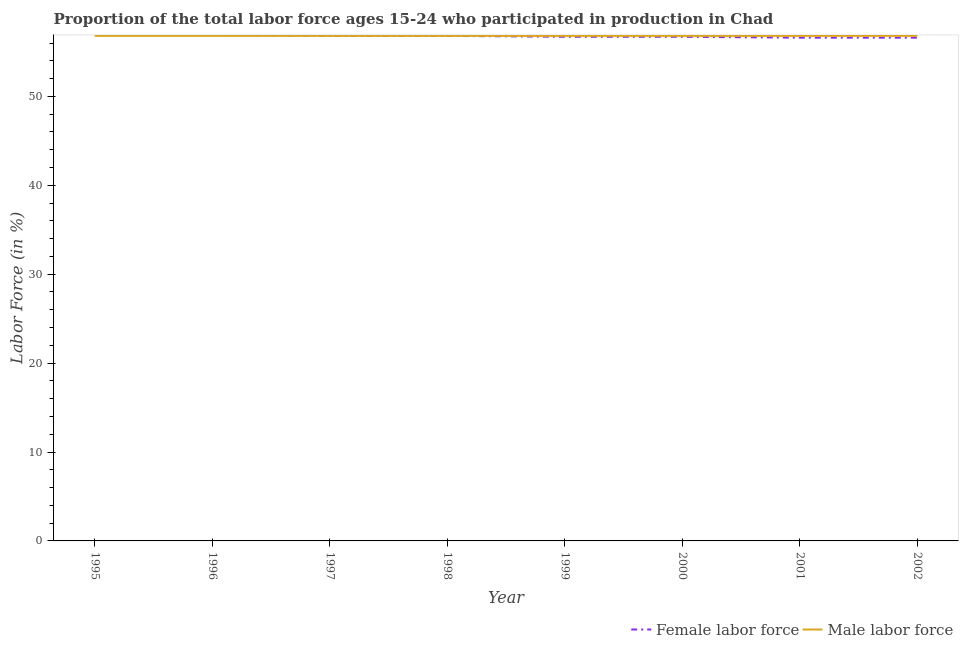How many different coloured lines are there?
Keep it short and to the point. 2. What is the percentage of male labour force in 1998?
Keep it short and to the point. 56.8. Across all years, what is the maximum percentage of female labor force?
Offer a very short reply. 56.9. Across all years, what is the minimum percentage of male labour force?
Your response must be concise. 56.8. In which year was the percentage of male labour force maximum?
Provide a short and direct response. 1995. In which year was the percentage of female labor force minimum?
Provide a succinct answer. 2001. What is the total percentage of male labour force in the graph?
Make the answer very short. 454.4. What is the difference between the percentage of female labor force in 1998 and that in 2001?
Provide a succinct answer. 0.2. What is the difference between the percentage of female labor force in 1998 and the percentage of male labour force in 2001?
Offer a very short reply. 0. What is the average percentage of female labor force per year?
Your response must be concise. 56.75. In the year 1998, what is the difference between the percentage of female labor force and percentage of male labour force?
Your response must be concise. 0. In how many years, is the percentage of male labour force greater than 36 %?
Provide a succinct answer. 8. What is the difference between the highest and the lowest percentage of female labor force?
Give a very brief answer. 0.3. Is the percentage of male labour force strictly less than the percentage of female labor force over the years?
Provide a short and direct response. No. How many lines are there?
Your answer should be very brief. 2. How many years are there in the graph?
Your answer should be very brief. 8. What is the difference between two consecutive major ticks on the Y-axis?
Make the answer very short. 10. Are the values on the major ticks of Y-axis written in scientific E-notation?
Ensure brevity in your answer.  No. Does the graph contain grids?
Offer a terse response. No. What is the title of the graph?
Give a very brief answer. Proportion of the total labor force ages 15-24 who participated in production in Chad. Does "Unregistered firms" appear as one of the legend labels in the graph?
Your response must be concise. No. What is the label or title of the X-axis?
Give a very brief answer. Year. What is the Labor Force (in %) of Female labor force in 1995?
Your answer should be very brief. 56.9. What is the Labor Force (in %) in Male labor force in 1995?
Your answer should be compact. 56.8. What is the Labor Force (in %) of Female labor force in 1996?
Offer a very short reply. 56.9. What is the Labor Force (in %) of Male labor force in 1996?
Your answer should be very brief. 56.8. What is the Labor Force (in %) of Female labor force in 1997?
Make the answer very short. 56.8. What is the Labor Force (in %) in Male labor force in 1997?
Your response must be concise. 56.8. What is the Labor Force (in %) of Female labor force in 1998?
Ensure brevity in your answer.  56.8. What is the Labor Force (in %) of Male labor force in 1998?
Keep it short and to the point. 56.8. What is the Labor Force (in %) in Female labor force in 1999?
Ensure brevity in your answer.  56.7. What is the Labor Force (in %) in Male labor force in 1999?
Provide a succinct answer. 56.8. What is the Labor Force (in %) of Female labor force in 2000?
Provide a succinct answer. 56.7. What is the Labor Force (in %) of Male labor force in 2000?
Give a very brief answer. 56.8. What is the Labor Force (in %) of Female labor force in 2001?
Provide a succinct answer. 56.6. What is the Labor Force (in %) of Male labor force in 2001?
Provide a succinct answer. 56.8. What is the Labor Force (in %) in Female labor force in 2002?
Your response must be concise. 56.6. What is the Labor Force (in %) of Male labor force in 2002?
Ensure brevity in your answer.  56.8. Across all years, what is the maximum Labor Force (in %) of Female labor force?
Give a very brief answer. 56.9. Across all years, what is the maximum Labor Force (in %) in Male labor force?
Provide a short and direct response. 56.8. Across all years, what is the minimum Labor Force (in %) of Female labor force?
Make the answer very short. 56.6. Across all years, what is the minimum Labor Force (in %) in Male labor force?
Give a very brief answer. 56.8. What is the total Labor Force (in %) in Female labor force in the graph?
Ensure brevity in your answer.  454. What is the total Labor Force (in %) of Male labor force in the graph?
Give a very brief answer. 454.4. What is the difference between the Labor Force (in %) in Male labor force in 1995 and that in 1997?
Offer a terse response. 0. What is the difference between the Labor Force (in %) in Male labor force in 1995 and that in 1998?
Provide a succinct answer. 0. What is the difference between the Labor Force (in %) of Female labor force in 1995 and that in 1999?
Make the answer very short. 0.2. What is the difference between the Labor Force (in %) in Female labor force in 1995 and that in 2000?
Provide a succinct answer. 0.2. What is the difference between the Labor Force (in %) of Female labor force in 1995 and that in 2001?
Offer a terse response. 0.3. What is the difference between the Labor Force (in %) in Female labor force in 1995 and that in 2002?
Your answer should be compact. 0.3. What is the difference between the Labor Force (in %) in Male labor force in 1995 and that in 2002?
Provide a short and direct response. 0. What is the difference between the Labor Force (in %) of Male labor force in 1996 and that in 1998?
Provide a succinct answer. 0. What is the difference between the Labor Force (in %) of Female labor force in 1996 and that in 1999?
Provide a succinct answer. 0.2. What is the difference between the Labor Force (in %) of Male labor force in 1996 and that in 1999?
Offer a very short reply. 0. What is the difference between the Labor Force (in %) in Female labor force in 1996 and that in 2001?
Offer a terse response. 0.3. What is the difference between the Labor Force (in %) of Male labor force in 1996 and that in 2001?
Provide a short and direct response. 0. What is the difference between the Labor Force (in %) of Male labor force in 1997 and that in 1998?
Give a very brief answer. 0. What is the difference between the Labor Force (in %) in Female labor force in 1997 and that in 2001?
Provide a succinct answer. 0.2. What is the difference between the Labor Force (in %) of Female labor force in 1997 and that in 2002?
Your answer should be compact. 0.2. What is the difference between the Labor Force (in %) of Male labor force in 1997 and that in 2002?
Your answer should be very brief. 0. What is the difference between the Labor Force (in %) of Male labor force in 1998 and that in 1999?
Your answer should be very brief. 0. What is the difference between the Labor Force (in %) of Female labor force in 1998 and that in 2001?
Ensure brevity in your answer.  0.2. What is the difference between the Labor Force (in %) of Female labor force in 1998 and that in 2002?
Keep it short and to the point. 0.2. What is the difference between the Labor Force (in %) in Male labor force in 1998 and that in 2002?
Provide a short and direct response. 0. What is the difference between the Labor Force (in %) in Female labor force in 1999 and that in 2002?
Keep it short and to the point. 0.1. What is the difference between the Labor Force (in %) in Male labor force in 1999 and that in 2002?
Provide a succinct answer. 0. What is the difference between the Labor Force (in %) of Female labor force in 2000 and that in 2001?
Your answer should be compact. 0.1. What is the difference between the Labor Force (in %) of Female labor force in 2000 and that in 2002?
Keep it short and to the point. 0.1. What is the difference between the Labor Force (in %) in Male labor force in 2000 and that in 2002?
Make the answer very short. 0. What is the difference between the Labor Force (in %) of Female labor force in 2001 and that in 2002?
Your answer should be compact. 0. What is the difference between the Labor Force (in %) in Male labor force in 2001 and that in 2002?
Keep it short and to the point. 0. What is the difference between the Labor Force (in %) in Female labor force in 1995 and the Labor Force (in %) in Male labor force in 1998?
Offer a very short reply. 0.1. What is the difference between the Labor Force (in %) in Female labor force in 1995 and the Labor Force (in %) in Male labor force in 1999?
Your response must be concise. 0.1. What is the difference between the Labor Force (in %) in Female labor force in 1995 and the Labor Force (in %) in Male labor force in 2001?
Your answer should be compact. 0.1. What is the difference between the Labor Force (in %) in Female labor force in 1996 and the Labor Force (in %) in Male labor force in 1998?
Your answer should be very brief. 0.1. What is the difference between the Labor Force (in %) of Female labor force in 1996 and the Labor Force (in %) of Male labor force in 2002?
Your answer should be compact. 0.1. What is the difference between the Labor Force (in %) in Female labor force in 1997 and the Labor Force (in %) in Male labor force in 1998?
Make the answer very short. 0. What is the difference between the Labor Force (in %) in Female labor force in 1997 and the Labor Force (in %) in Male labor force in 1999?
Your response must be concise. 0. What is the difference between the Labor Force (in %) in Female labor force in 1997 and the Labor Force (in %) in Male labor force in 2001?
Offer a terse response. 0. What is the difference between the Labor Force (in %) of Female labor force in 1998 and the Labor Force (in %) of Male labor force in 1999?
Your answer should be compact. 0. What is the difference between the Labor Force (in %) of Female labor force in 1998 and the Labor Force (in %) of Male labor force in 2001?
Your answer should be compact. 0. What is the difference between the Labor Force (in %) of Female labor force in 1999 and the Labor Force (in %) of Male labor force in 2001?
Give a very brief answer. -0.1. What is the difference between the Labor Force (in %) in Female labor force in 1999 and the Labor Force (in %) in Male labor force in 2002?
Your response must be concise. -0.1. What is the difference between the Labor Force (in %) in Female labor force in 2000 and the Labor Force (in %) in Male labor force in 2001?
Your answer should be compact. -0.1. What is the difference between the Labor Force (in %) of Female labor force in 2000 and the Labor Force (in %) of Male labor force in 2002?
Provide a short and direct response. -0.1. What is the average Labor Force (in %) in Female labor force per year?
Your response must be concise. 56.75. What is the average Labor Force (in %) of Male labor force per year?
Provide a short and direct response. 56.8. In the year 1996, what is the difference between the Labor Force (in %) of Female labor force and Labor Force (in %) of Male labor force?
Offer a very short reply. 0.1. In the year 1997, what is the difference between the Labor Force (in %) in Female labor force and Labor Force (in %) in Male labor force?
Offer a terse response. 0. In the year 1999, what is the difference between the Labor Force (in %) of Female labor force and Labor Force (in %) of Male labor force?
Provide a short and direct response. -0.1. In the year 2000, what is the difference between the Labor Force (in %) in Female labor force and Labor Force (in %) in Male labor force?
Provide a short and direct response. -0.1. In the year 2002, what is the difference between the Labor Force (in %) of Female labor force and Labor Force (in %) of Male labor force?
Keep it short and to the point. -0.2. What is the ratio of the Labor Force (in %) in Female labor force in 1995 to that in 1996?
Your answer should be compact. 1. What is the ratio of the Labor Force (in %) in Male labor force in 1995 to that in 1996?
Your answer should be compact. 1. What is the ratio of the Labor Force (in %) in Male labor force in 1995 to that in 1997?
Provide a short and direct response. 1. What is the ratio of the Labor Force (in %) of Female labor force in 1995 to that in 1998?
Keep it short and to the point. 1. What is the ratio of the Labor Force (in %) in Male labor force in 1995 to that in 1998?
Offer a very short reply. 1. What is the ratio of the Labor Force (in %) of Female labor force in 1995 to that in 1999?
Offer a terse response. 1. What is the ratio of the Labor Force (in %) in Male labor force in 1995 to that in 2000?
Your answer should be compact. 1. What is the ratio of the Labor Force (in %) of Male labor force in 1995 to that in 2001?
Offer a terse response. 1. What is the ratio of the Labor Force (in %) of Female labor force in 1995 to that in 2002?
Offer a terse response. 1.01. What is the ratio of the Labor Force (in %) in Male labor force in 1996 to that in 1997?
Give a very brief answer. 1. What is the ratio of the Labor Force (in %) in Male labor force in 1996 to that in 1998?
Your response must be concise. 1. What is the ratio of the Labor Force (in %) in Female labor force in 1996 to that in 1999?
Make the answer very short. 1. What is the ratio of the Labor Force (in %) in Female labor force in 1996 to that in 2001?
Your answer should be very brief. 1.01. What is the ratio of the Labor Force (in %) in Male labor force in 1996 to that in 2001?
Ensure brevity in your answer.  1. What is the ratio of the Labor Force (in %) in Female labor force in 1997 to that in 1999?
Offer a very short reply. 1. What is the ratio of the Labor Force (in %) of Male labor force in 1997 to that in 2000?
Ensure brevity in your answer.  1. What is the ratio of the Labor Force (in %) in Female labor force in 1997 to that in 2001?
Your response must be concise. 1. What is the ratio of the Labor Force (in %) of Female labor force in 1997 to that in 2002?
Make the answer very short. 1. What is the ratio of the Labor Force (in %) of Male labor force in 1998 to that in 2001?
Ensure brevity in your answer.  1. What is the ratio of the Labor Force (in %) in Female labor force in 1998 to that in 2002?
Offer a terse response. 1. What is the ratio of the Labor Force (in %) of Male labor force in 1998 to that in 2002?
Your response must be concise. 1. What is the ratio of the Labor Force (in %) of Female labor force in 1999 to that in 2000?
Give a very brief answer. 1. What is the ratio of the Labor Force (in %) of Female labor force in 2000 to that in 2001?
Make the answer very short. 1. What is the ratio of the Labor Force (in %) of Female labor force in 2000 to that in 2002?
Offer a very short reply. 1. What is the ratio of the Labor Force (in %) of Male labor force in 2000 to that in 2002?
Provide a succinct answer. 1. What is the ratio of the Labor Force (in %) in Male labor force in 2001 to that in 2002?
Give a very brief answer. 1. What is the difference between the highest and the second highest Labor Force (in %) of Female labor force?
Ensure brevity in your answer.  0. What is the difference between the highest and the second highest Labor Force (in %) of Male labor force?
Keep it short and to the point. 0. 